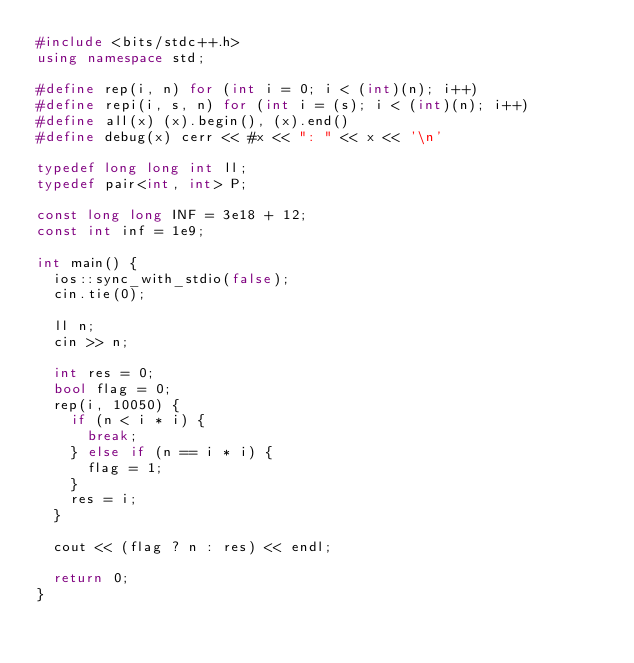Convert code to text. <code><loc_0><loc_0><loc_500><loc_500><_C++_>#include <bits/stdc++.h>
using namespace std;

#define rep(i, n) for (int i = 0; i < (int)(n); i++)
#define repi(i, s, n) for (int i = (s); i < (int)(n); i++)
#define all(x) (x).begin(), (x).end()
#define debug(x) cerr << #x << ": " << x << '\n'

typedef long long int ll;
typedef pair<int, int> P;

const long long INF = 3e18 + 12;
const int inf = 1e9;

int main() {
  ios::sync_with_stdio(false);
  cin.tie(0);

  ll n;
  cin >> n;

  int res = 0;
  bool flag = 0;
  rep(i, 10050) {
    if (n < i * i) {
      break;
    } else if (n == i * i) {
      flag = 1;
    }
    res = i;
  }

  cout << (flag ? n : res) << endl;

  return 0;
}</code> 